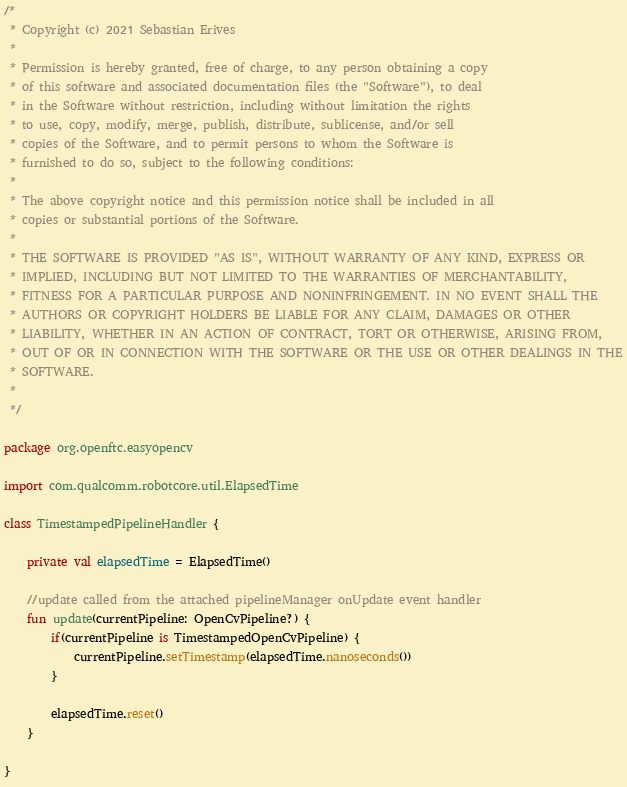Convert code to text. <code><loc_0><loc_0><loc_500><loc_500><_Kotlin_>/*
 * Copyright (c) 2021 Sebastian Erives
 *
 * Permission is hereby granted, free of charge, to any person obtaining a copy
 * of this software and associated documentation files (the "Software"), to deal
 * in the Software without restriction, including without limitation the rights
 * to use, copy, modify, merge, publish, distribute, sublicense, and/or sell
 * copies of the Software, and to permit persons to whom the Software is
 * furnished to do so, subject to the following conditions:
 *
 * The above copyright notice and this permission notice shall be included in all
 * copies or substantial portions of the Software.
 *
 * THE SOFTWARE IS PROVIDED "AS IS", WITHOUT WARRANTY OF ANY KIND, EXPRESS OR
 * IMPLIED, INCLUDING BUT NOT LIMITED TO THE WARRANTIES OF MERCHANTABILITY,
 * FITNESS FOR A PARTICULAR PURPOSE AND NONINFRINGEMENT. IN NO EVENT SHALL THE
 * AUTHORS OR COPYRIGHT HOLDERS BE LIABLE FOR ANY CLAIM, DAMAGES OR OTHER
 * LIABILITY, WHETHER IN AN ACTION OF CONTRACT, TORT OR OTHERWISE, ARISING FROM,
 * OUT OF OR IN CONNECTION WITH THE SOFTWARE OR THE USE OR OTHER DEALINGS IN THE
 * SOFTWARE.
 *
 */

package org.openftc.easyopencv

import com.qualcomm.robotcore.util.ElapsedTime

class TimestampedPipelineHandler {

    private val elapsedTime = ElapsedTime()

    //update called from the attached pipelineManager onUpdate event handler
    fun update(currentPipeline: OpenCvPipeline?) {
        if(currentPipeline is TimestampedOpenCvPipeline) {
            currentPipeline.setTimestamp(elapsedTime.nanoseconds())
        }

        elapsedTime.reset()
    }

}</code> 